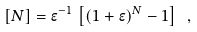Convert formula to latex. <formula><loc_0><loc_0><loc_500><loc_500>[ N ] = \epsilon ^ { - 1 } \, \left [ ( 1 + \epsilon ) ^ { N } - 1 \right ] \ ,</formula> 